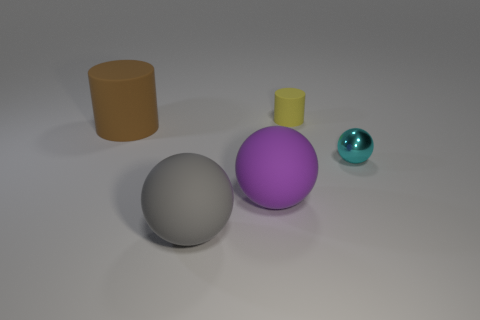Are there any other things that are the same material as the cyan ball?
Give a very brief answer. No. Is the sphere on the right side of the small cylinder made of the same material as the large gray thing?
Give a very brief answer. No. Is there a yellow object?
Your response must be concise. Yes. There is a matte thing that is behind the purple thing and to the right of the gray thing; how big is it?
Offer a very short reply. Small. Is the number of small cyan balls left of the metal thing greater than the number of brown rubber cylinders that are behind the tiny yellow rubber cylinder?
Make the answer very short. No. What color is the metallic ball?
Your response must be concise. Cyan. The sphere that is both left of the small cyan ball and behind the big gray sphere is what color?
Keep it short and to the point. Purple. The cylinder that is behind the thing that is to the left of the large object in front of the purple matte ball is what color?
Provide a succinct answer. Yellow. The rubber cylinder that is the same size as the shiny object is what color?
Give a very brief answer. Yellow. There is a large thing behind the large rubber thing to the right of the big ball that is left of the purple rubber object; what shape is it?
Provide a succinct answer. Cylinder. 